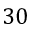<formula> <loc_0><loc_0><loc_500><loc_500>3 0</formula> 